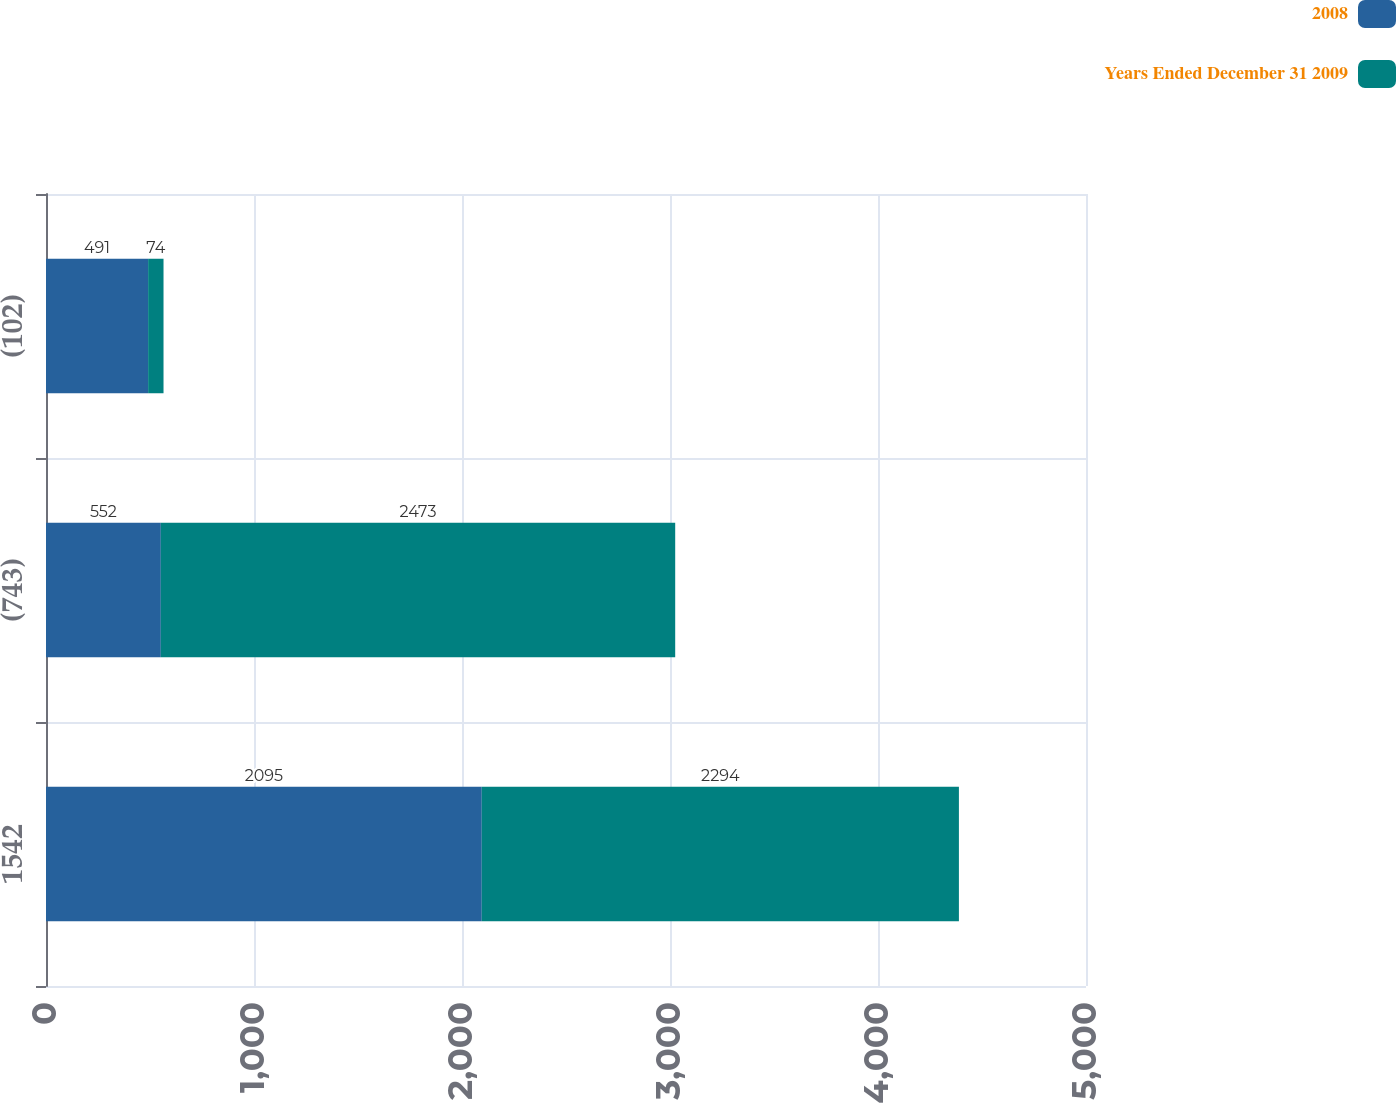Convert chart to OTSL. <chart><loc_0><loc_0><loc_500><loc_500><stacked_bar_chart><ecel><fcel>1542<fcel>(743)<fcel>(102)<nl><fcel>2008<fcel>2095<fcel>552<fcel>491<nl><fcel>Years Ended December 31 2009<fcel>2294<fcel>2473<fcel>74<nl></chart> 